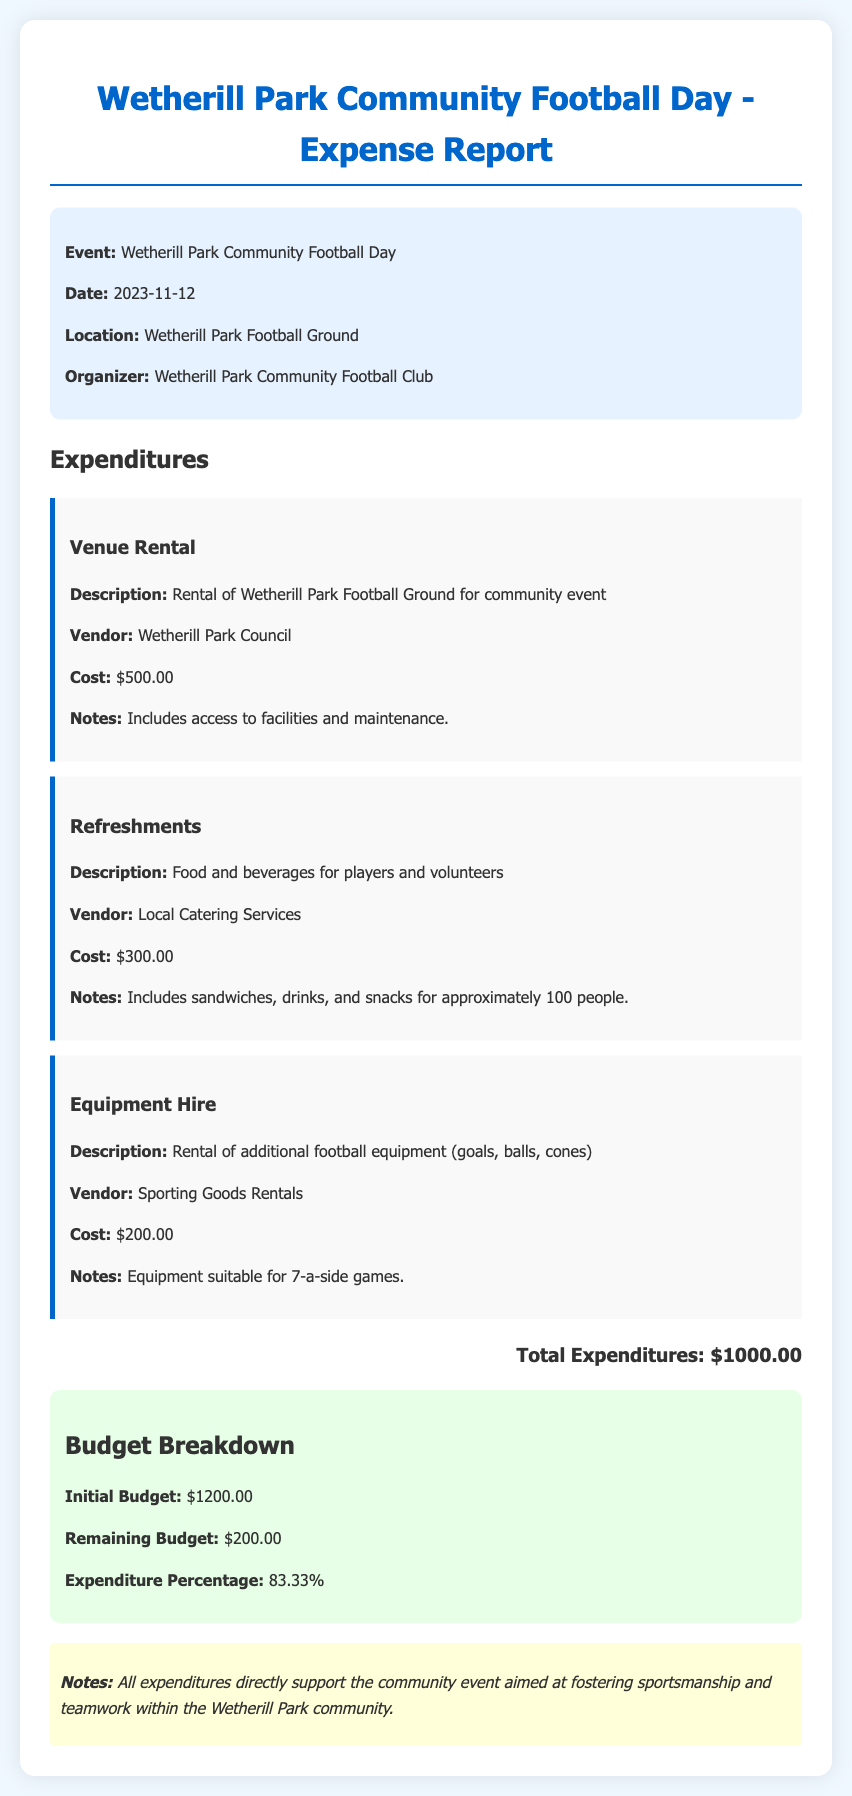What is the total expenditure? The total expenditure is clearly stated in the document as the sum of all expenses listed, which is $500 for venue rental, $300 for refreshments, and $200 for equipment hire.
Answer: $1000.00 What is the date of the event? The date of the event is specified in the event details section of the document.
Answer: 2023-11-12 Who is the vendor for refreshments? The vendor for refreshments is mentioned under the refreshments expenditure details.
Answer: Local Catering Services What percentage of the budget was spent? The expenditure percentage is calculated based on total expenditures compared to the initial budget provided in the document.
Answer: 83.33% What is the remaining budget after expenditures? The remaining budget is highlighted in the budget breakdown section, calculated as the initial budget minus total expenditures.
Answer: $200.00 What is the cost of equipment hire? The cost of equipment hire is explicitly stated in the document under the equipment hire expenditure section.
Answer: $200.00 What was rented from the vendor Sporting Goods Rentals? The document describes the item rented under the equipment hire section, indicating what items were sourced for the event.
Answer: Additional football equipment (goals, balls, cones) Which council is listed as the venue vendor? The venue rental section of the document names the council handling the venue rental charges.
Answer: Wetherill Park Council What is the initial budget for the event? The initial budget is provided in the budget breakdown section as the starting funds allotted for the event.
Answer: $1200.00 